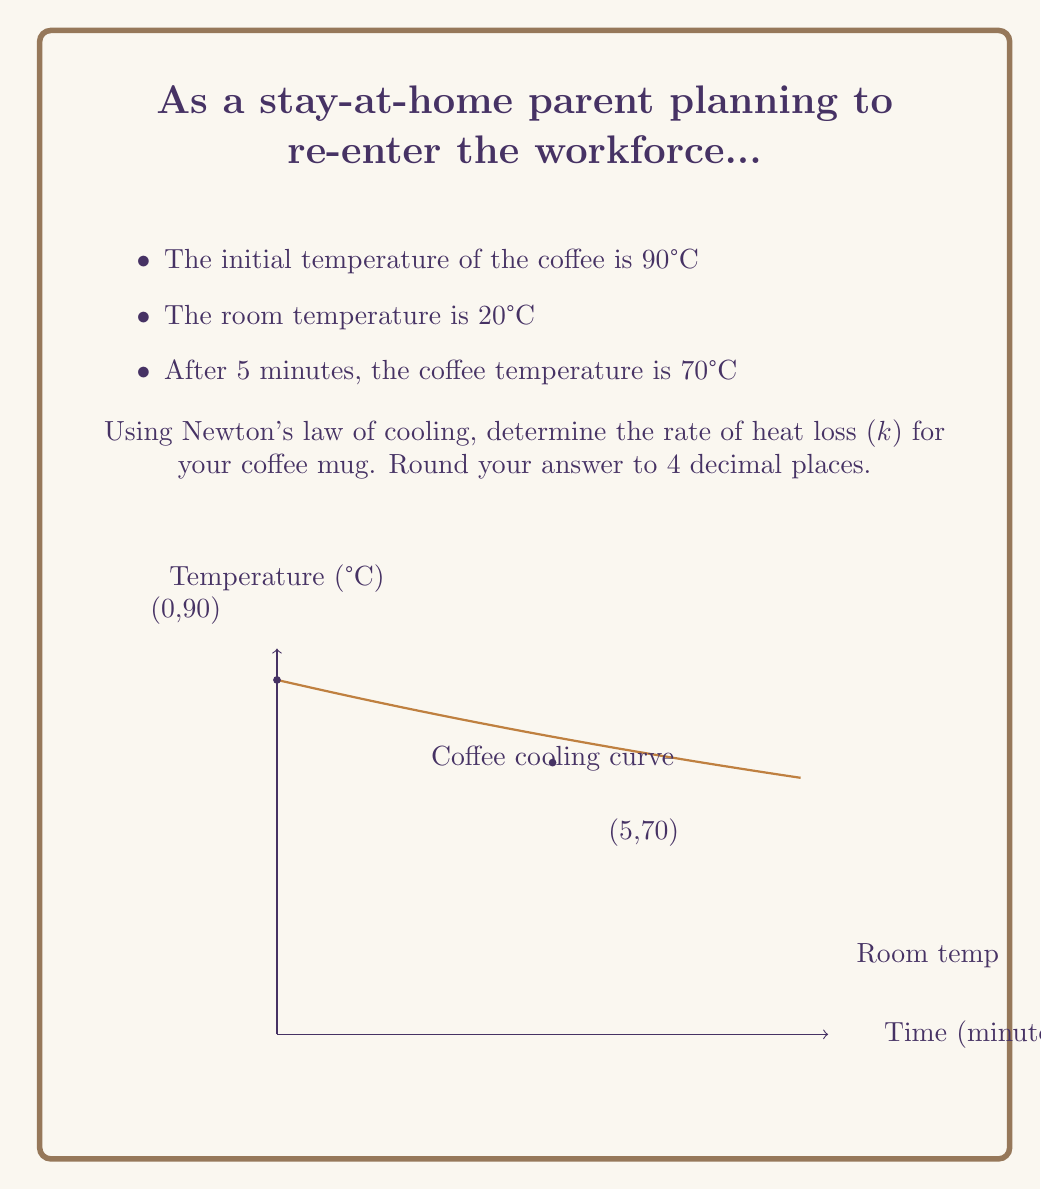Can you answer this question? Let's solve this step-by-step using Newton's law of cooling:

1) Newton's law of cooling is given by the differential equation:
   $$\frac{dT}{dt} = -k(T - T_s)$$
   where $T$ is the temperature of the coffee, $T_s$ is the surrounding temperature, and $k$ is the cooling rate.

2) The solution to this differential equation is:
   $$T(t) = T_s + (T_0 - T_s)e^{-kt}$$
   where $T_0$ is the initial temperature.

3) We know:
   $T_0 = 90°C$
   $T_s = 20°C$
   At $t = 5$ minutes, $T = 70°C$

4) Substituting these values into the equation:
   $$70 = 20 + (90 - 20)e^{-5k}$$

5) Simplifying:
   $$50 = 70e^{-5k}$$

6) Dividing both sides by 70:
   $$\frac{5}{7} = e^{-5k}$$

7) Taking the natural log of both sides:
   $$\ln(\frac{5}{7}) = -5k$$

8) Solving for $k$:
   $$k = -\frac{1}{5}\ln(\frac{5}{7}) \approx 0.0462$$

9) Rounding to 4 decimal places:
   $$k \approx 0.0462$$
Answer: $k \approx 0.0462$ min^(-1) 